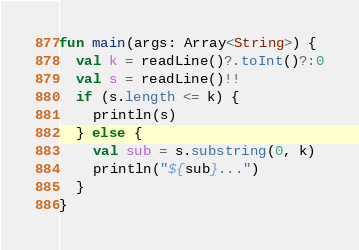<code> <loc_0><loc_0><loc_500><loc_500><_Kotlin_>fun main(args: Array<String>) {
  val k = readLine()?.toInt()?:0
  val s = readLine()!!
  if (s.length <= k) {
    println(s)
  } else {
    val sub = s.substring(0, k)
    println("${sub}...")
  }
}</code> 